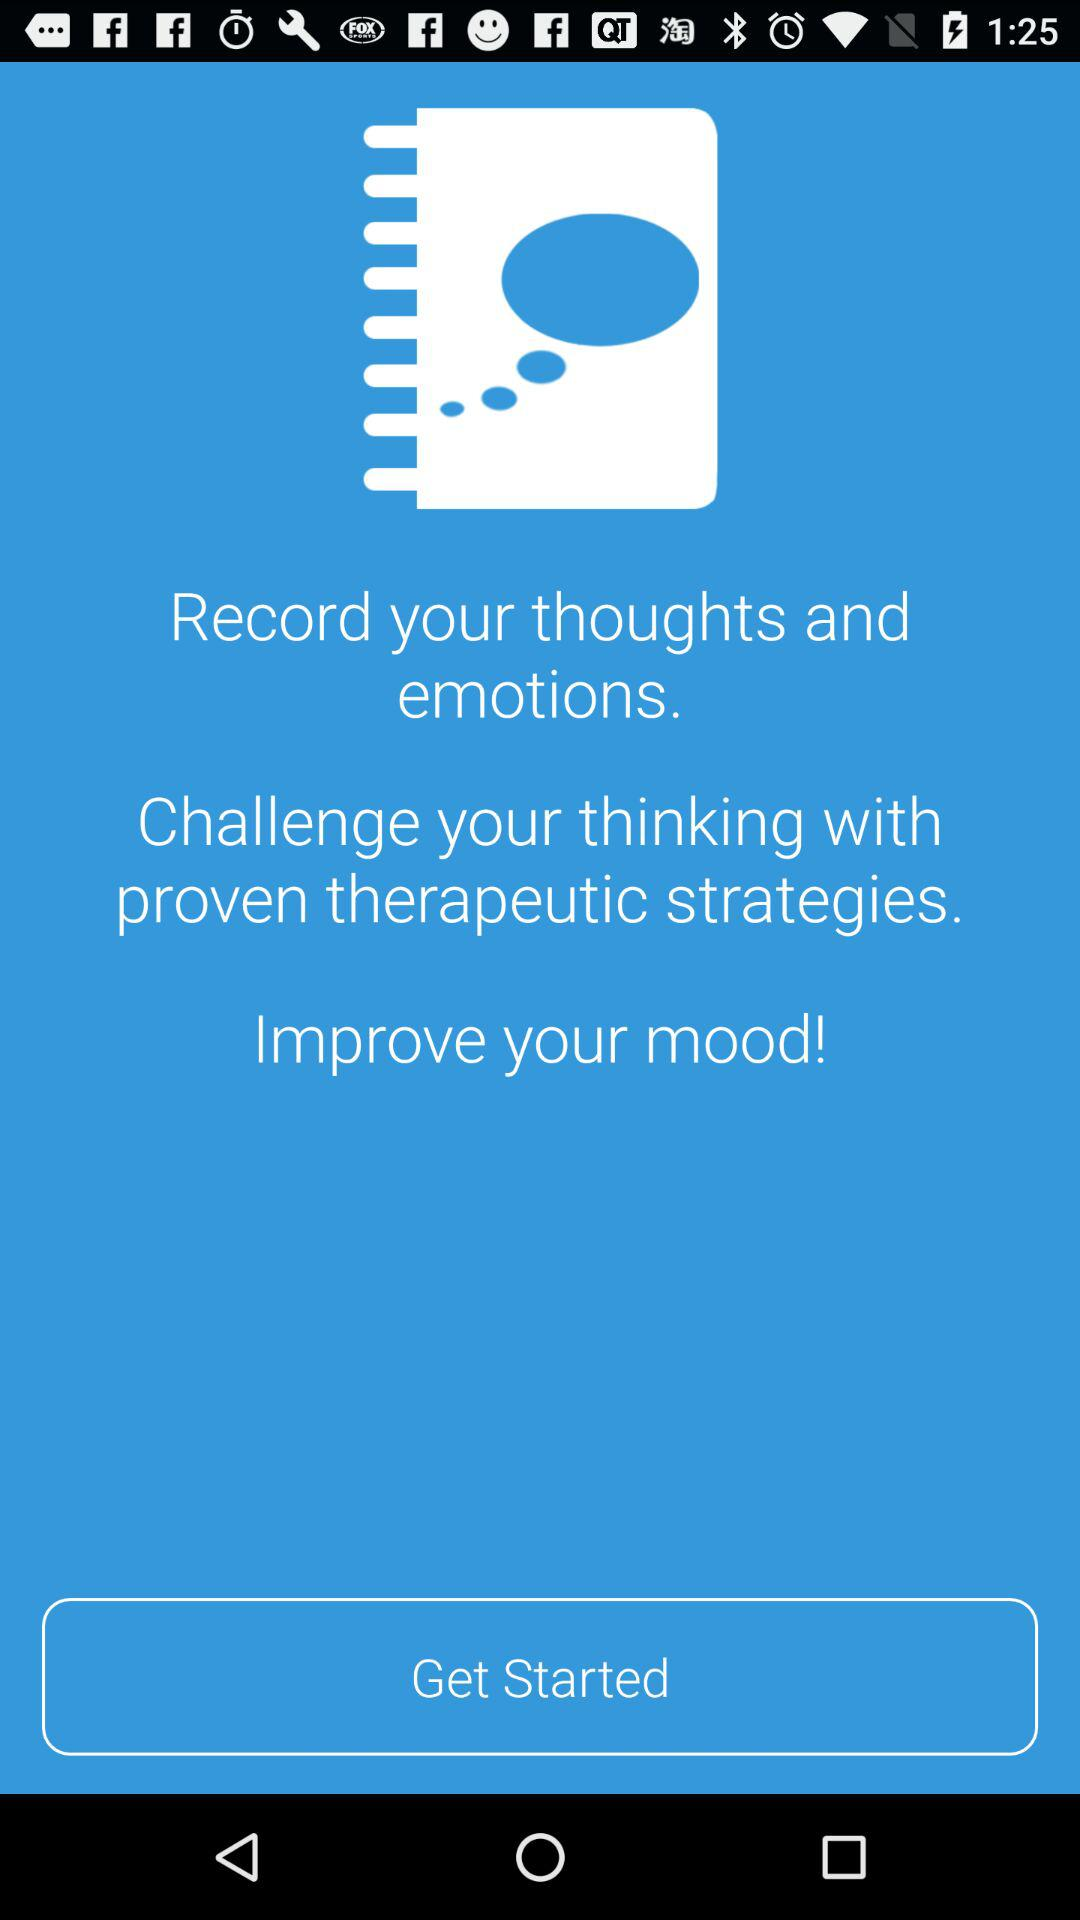What is the name of the application?
When the provided information is insufficient, respond with <no answer>. <no answer> 